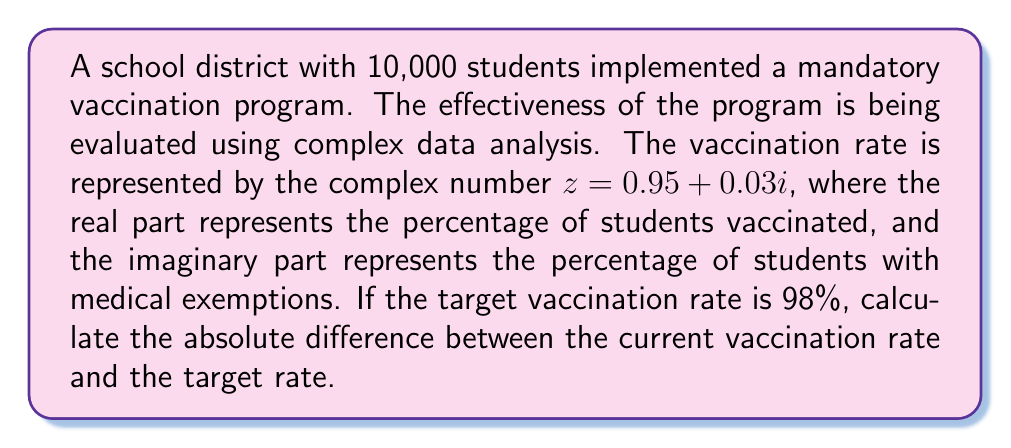Show me your answer to this math problem. To solve this problem, we need to follow these steps:

1) First, we need to understand what the complex number $z = 0.95 + 0.03i$ represents:
   - Real part (0.95): 95% of students are vaccinated
   - Imaginary part (0.03i): 3% of students have medical exemptions

2) The total coverage of the program is represented by the modulus of this complex number.
   To calculate the modulus, we use the formula: $|z| = \sqrt{a^2 + b^2}$, where $a$ is the real part and $b$ is the imaginary part.

3) Let's calculate the modulus:
   $$|z| = \sqrt{0.95^2 + 0.03^2} = \sqrt{0.9025 + 0.0009} = \sqrt{0.9034} \approx 0.9505$$

4) This means the current effective vaccination rate is approximately 95.05%

5) The target vaccination rate is 98% or 0.98

6) To find the absolute difference, we subtract the current rate from the target rate:
   $$|0.98 - 0.9505| = 0.0295$$

7) Convert to percentage: $0.0295 * 100 = 2.95\%$

Therefore, the vaccination program needs to improve by approximately 2.95 percentage points to reach the target rate.
Answer: 2.95% 